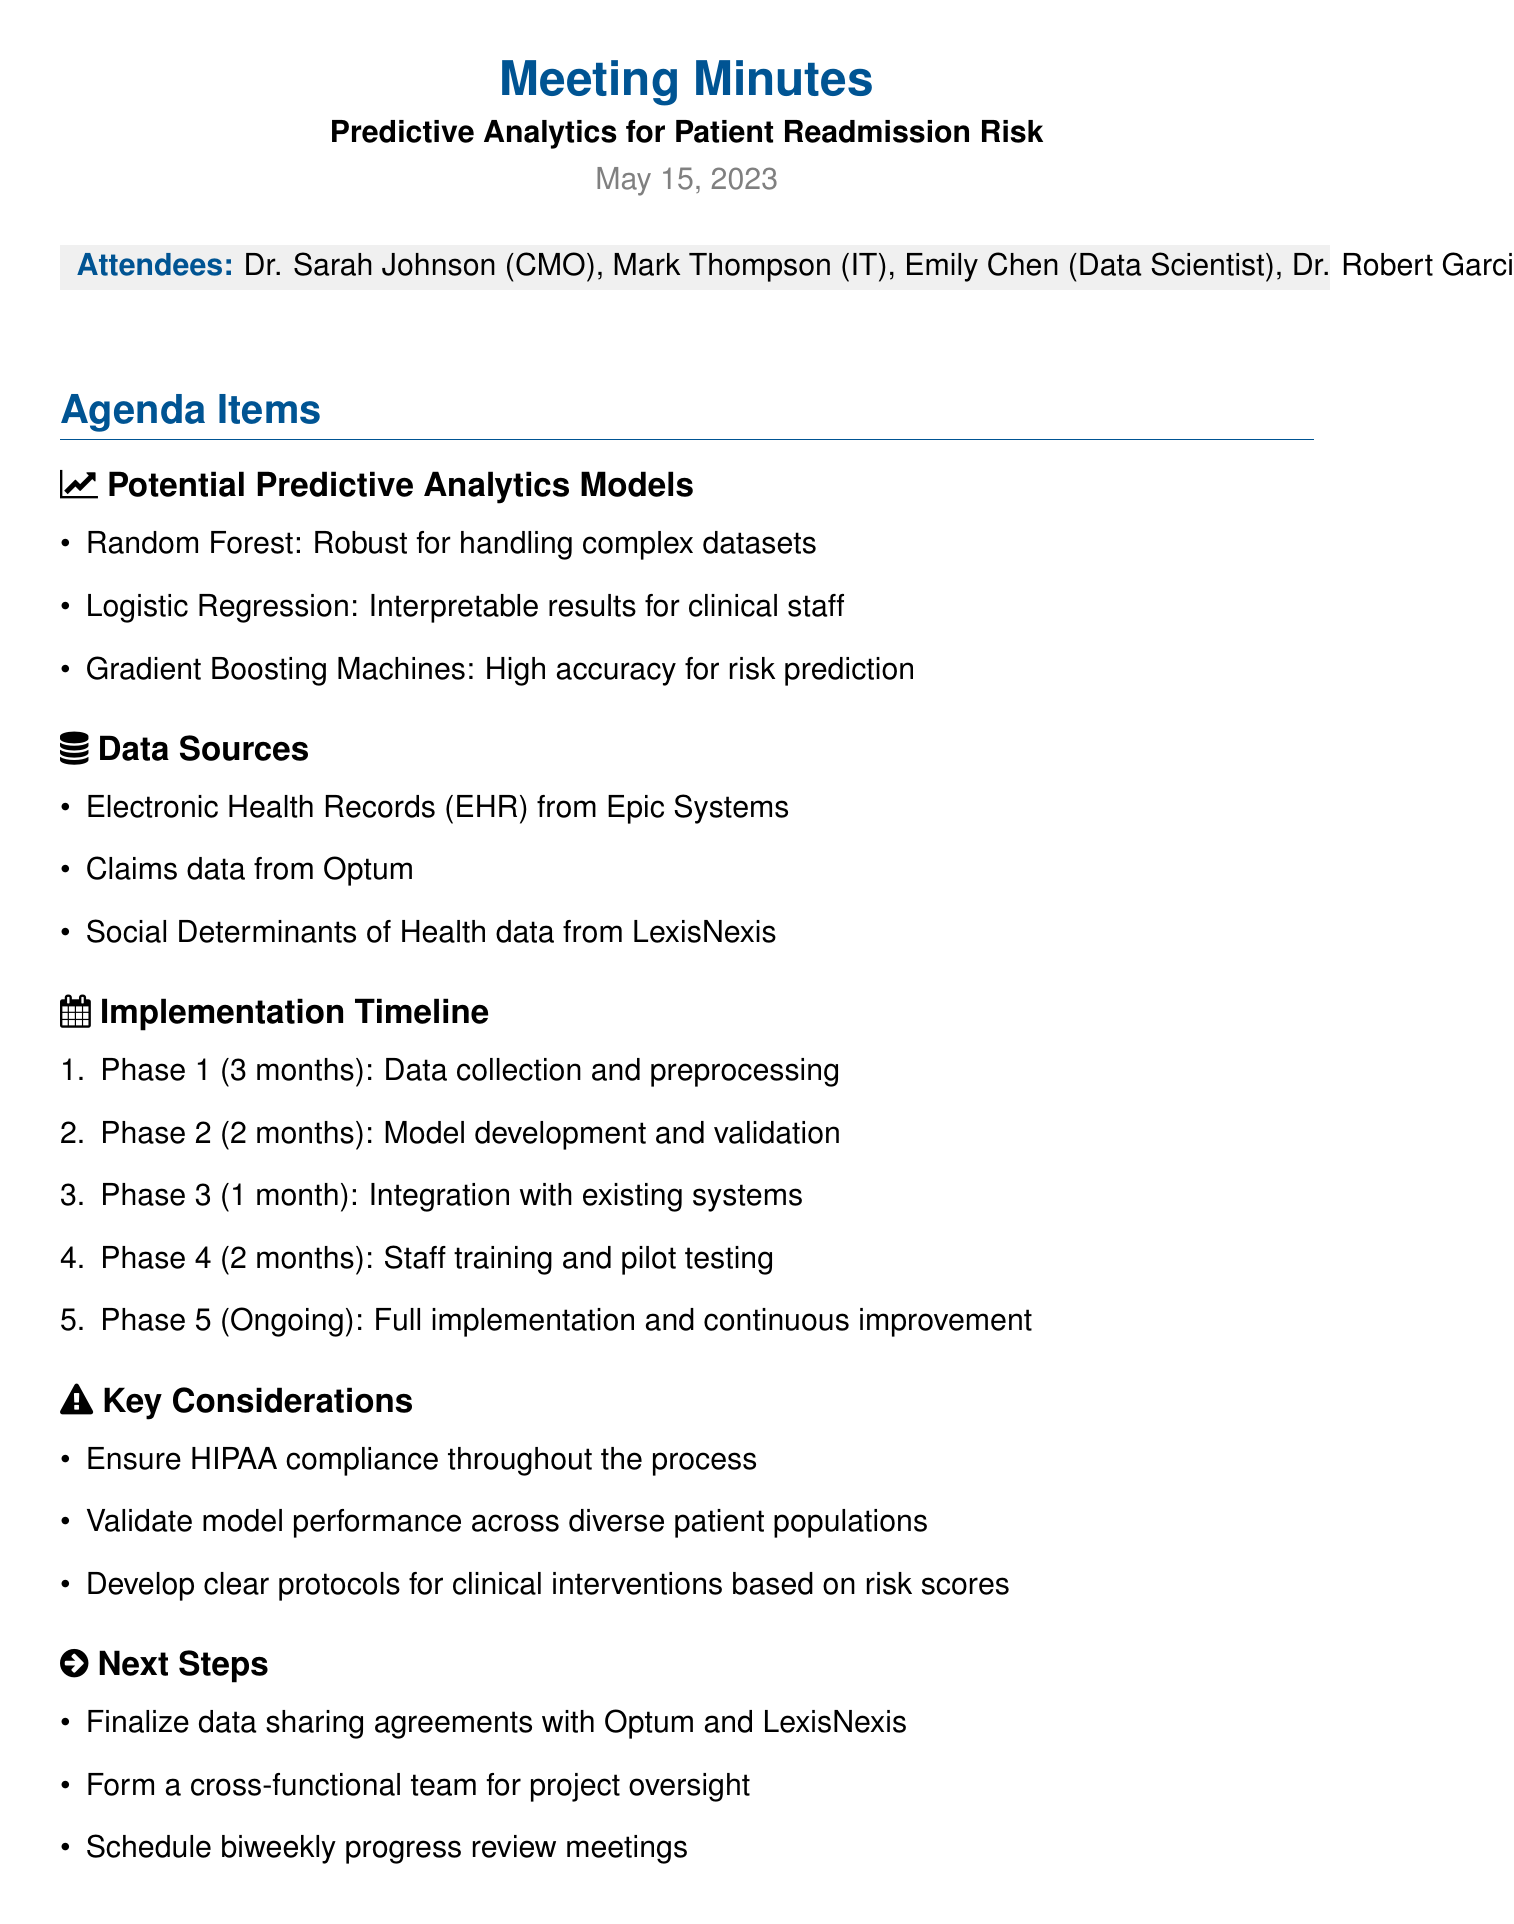What is the date of the meeting? The date of the meeting is mentioned at the beginning of the document.
Answer: May 15, 2023 Who is the Chief Medical Officer? The document lists attendees, including their titles.
Answer: Dr. Sarah Johnson What model is noted for high accuracy in risk prediction? The agenda items include potential predictive analytics models with their characteristics.
Answer: Gradient Boosting Machines How many phases are in the implementation timeline? The implementation timeline outlines the phases of the project.
Answer: Five What is the duration of Phase 1? The document specifies the duration for each phase in the implementation timeline.
Answer: Three months What is a key consideration mentioned in the meeting? The meeting minutes highlight important factors to consider during implementation.
Answer: Ensure HIPAA compliance What data source is mentioned for claims data? The data sources listed provide specifics on where data will be sourced from.
Answer: Optum What is the next step involving data sharing agreements? The next steps outline actions to be taken following the meeting.
Answer: Finalize data sharing agreements with Optum and LexisNexis 